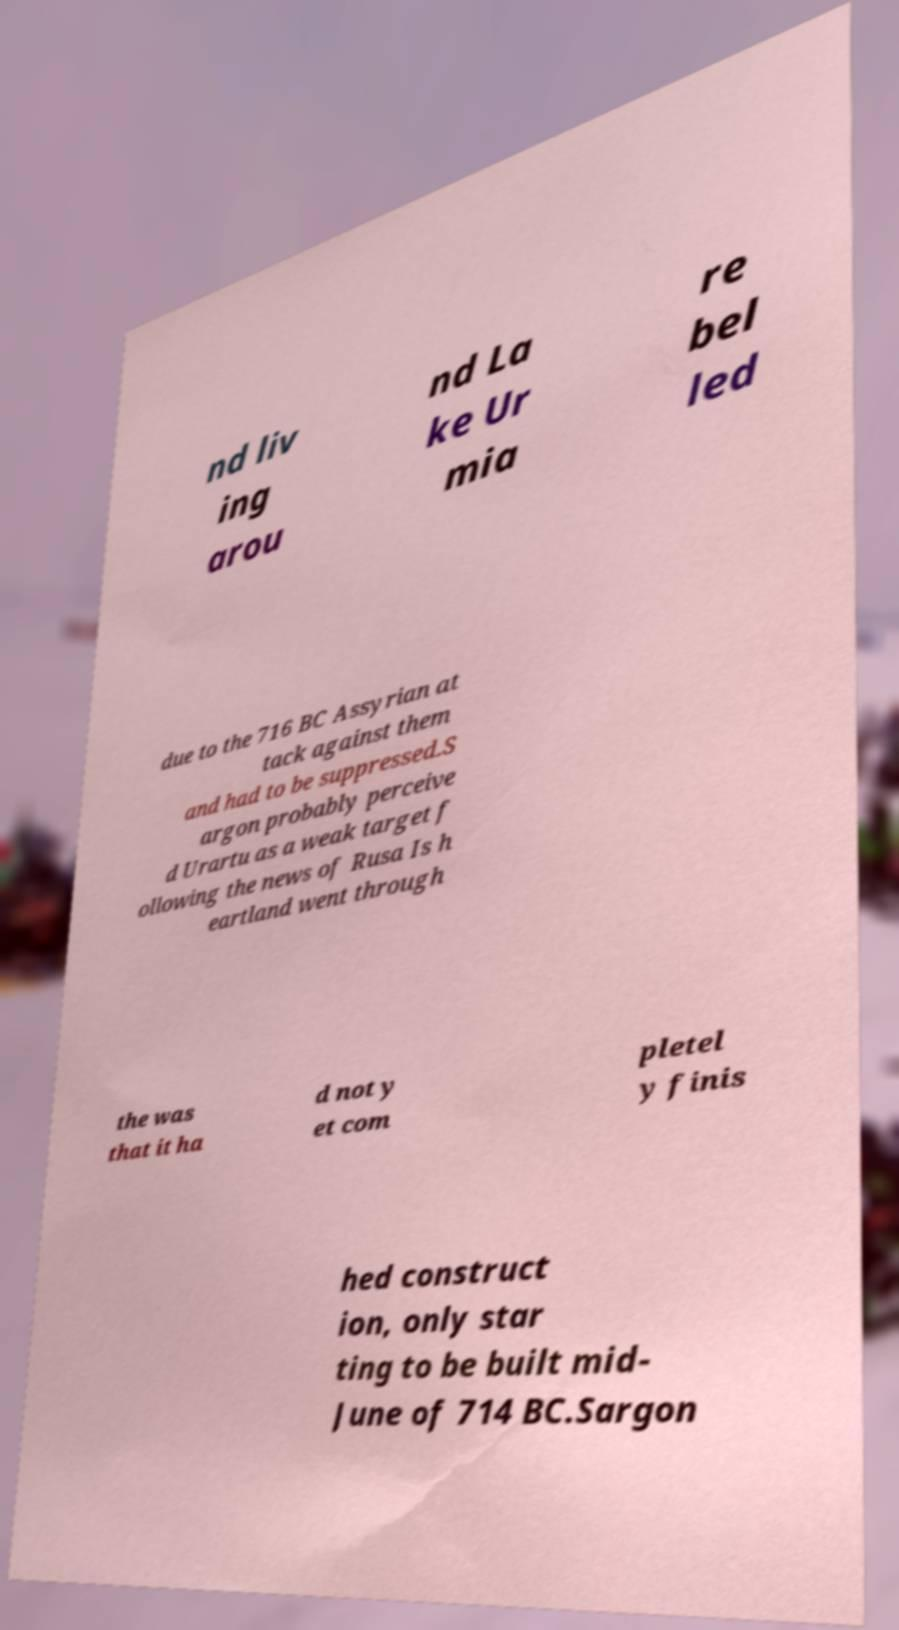For documentation purposes, I need the text within this image transcribed. Could you provide that? nd liv ing arou nd La ke Ur mia re bel led due to the 716 BC Assyrian at tack against them and had to be suppressed.S argon probably perceive d Urartu as a weak target f ollowing the news of Rusa Is h eartland went through the was that it ha d not y et com pletel y finis hed construct ion, only star ting to be built mid- June of 714 BC.Sargon 